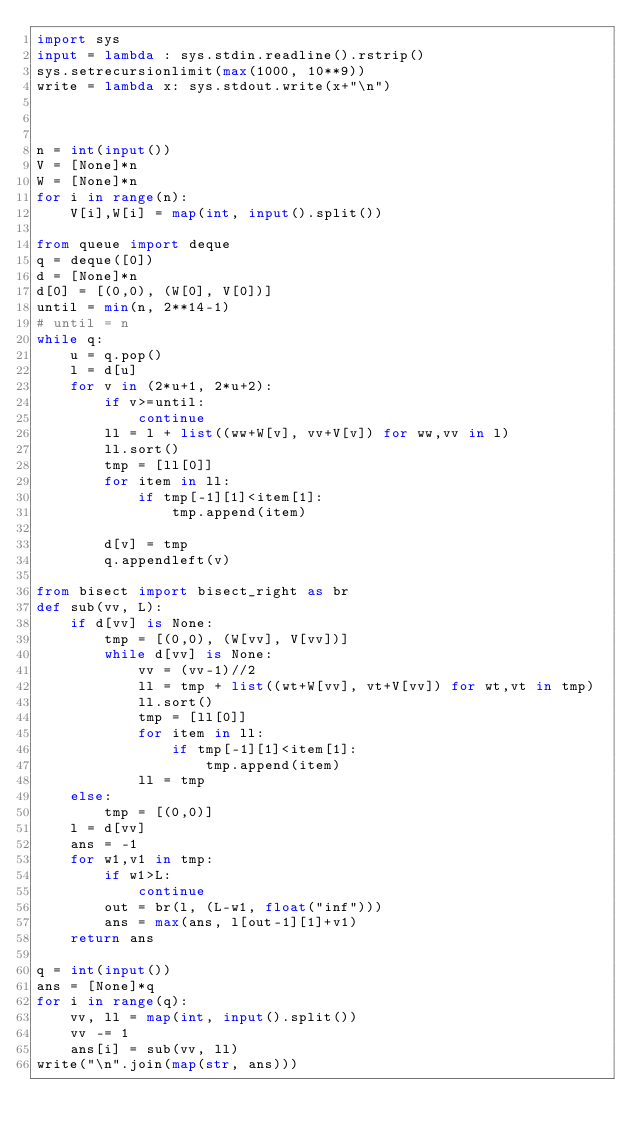Convert code to text. <code><loc_0><loc_0><loc_500><loc_500><_Python_>import sys
input = lambda : sys.stdin.readline().rstrip()
sys.setrecursionlimit(max(1000, 10**9))
write = lambda x: sys.stdout.write(x+"\n")



n = int(input())
V = [None]*n
W = [None]*n
for i in range(n):
    V[i],W[i] = map(int, input().split())

from queue import deque
q = deque([0])
d = [None]*n
d[0] = [(0,0), (W[0], V[0])]
until = min(n, 2**14-1)
# until = n
while q:
    u = q.pop()
    l = d[u]
    for v in (2*u+1, 2*u+2):
        if v>=until:
            continue
        ll = l + list((ww+W[v], vv+V[v]) for ww,vv in l)
        ll.sort()
        tmp = [ll[0]]
        for item in ll:
            if tmp[-1][1]<item[1]:
                tmp.append(item)
                
        d[v] = tmp
        q.appendleft(v)

from bisect import bisect_right as br
def sub(vv, L):
    if d[vv] is None:
        tmp = [(0,0), (W[vv], V[vv])]
        while d[vv] is None:
            vv = (vv-1)//2
            ll = tmp + list((wt+W[vv], vt+V[vv]) for wt,vt in tmp)
            ll.sort()
            tmp = [ll[0]]
            for item in ll:
                if tmp[-1][1]<item[1]:
                    tmp.append(item)
            ll = tmp
    else:
        tmp = [(0,0)]
    l = d[vv]
    ans = -1
    for w1,v1 in tmp:
        if w1>L:
            continue
        out = br(l, (L-w1, float("inf")))
        ans = max(ans, l[out-1][1]+v1)
    return ans
        
q = int(input())
ans = [None]*q
for i in range(q):
    vv, ll = map(int, input().split())
    vv -= 1
    ans[i] = sub(vv, ll)
write("\n".join(map(str, ans)))</code> 